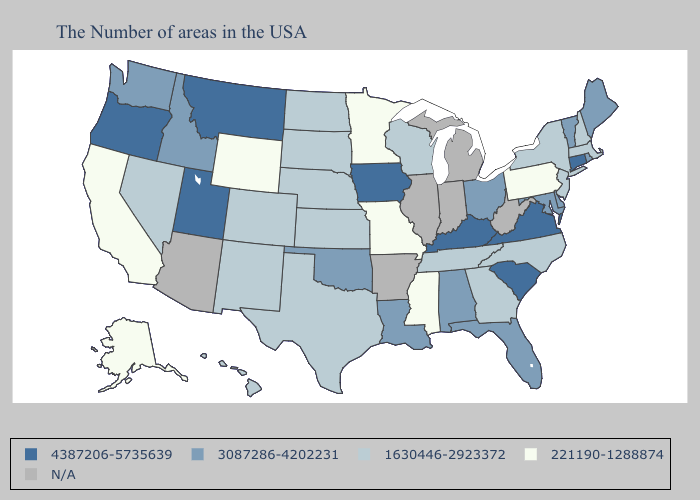Name the states that have a value in the range 1630446-2923372?
Keep it brief. Massachusetts, New Hampshire, New York, New Jersey, North Carolina, Georgia, Tennessee, Wisconsin, Kansas, Nebraska, Texas, South Dakota, North Dakota, Colorado, New Mexico, Nevada, Hawaii. Does Iowa have the highest value in the USA?
Write a very short answer. Yes. Does California have the lowest value in the West?
Quick response, please. Yes. What is the value of Louisiana?
Keep it brief. 3087286-4202231. Does Tennessee have the lowest value in the South?
Quick response, please. No. Is the legend a continuous bar?
Write a very short answer. No. Name the states that have a value in the range 4387206-5735639?
Concise answer only. Connecticut, Virginia, South Carolina, Kentucky, Iowa, Utah, Montana, Oregon. Name the states that have a value in the range 3087286-4202231?
Short answer required. Maine, Rhode Island, Vermont, Delaware, Maryland, Ohio, Florida, Alabama, Louisiana, Oklahoma, Idaho, Washington. Name the states that have a value in the range 221190-1288874?
Answer briefly. Pennsylvania, Mississippi, Missouri, Minnesota, Wyoming, California, Alaska. How many symbols are there in the legend?
Quick response, please. 5. What is the value of Nebraska?
Give a very brief answer. 1630446-2923372. What is the value of Oregon?
Answer briefly. 4387206-5735639. 